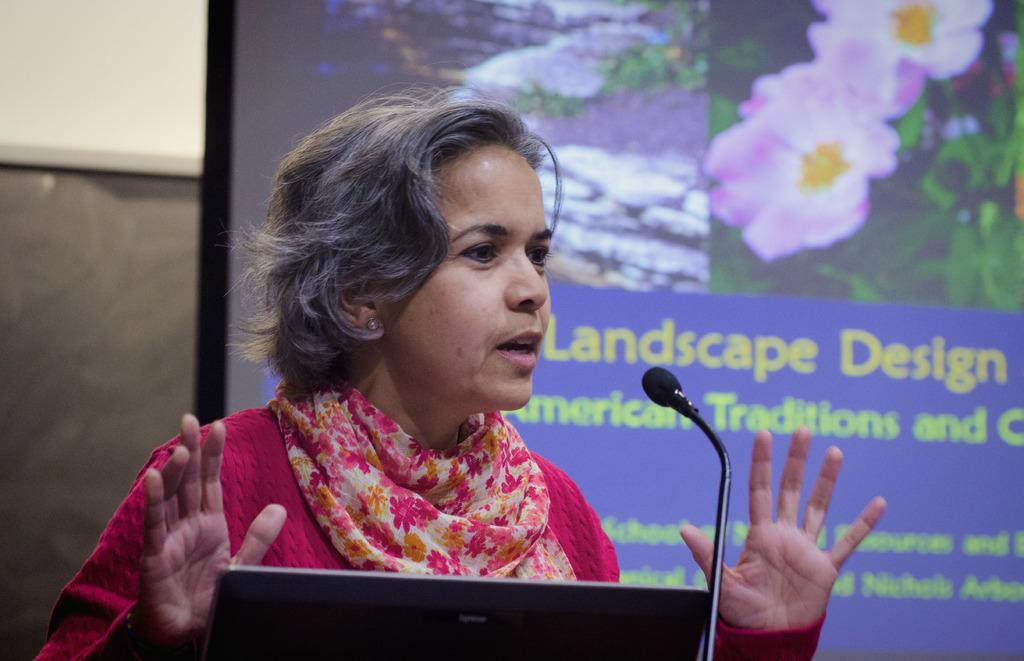What can be seen in the image related to a person? There is a person in the image, and they are wearing a pink top and a scarf. What electronic devices are present in the image? There is a laptop, a mic, and a projector screen in the image. What is written on the projector screen? Something is written on the projector screen, but the specific content is not mentioned in the facts. What is the person likely doing in the image? The presence of a laptop, mic, and projector screen suggests that the person might be giving a presentation or participating in a meeting. Can you describe the seashore in the image? There is no mention of a seashore in the image; it features a person, electronic devices, and a projector screen. What type of yard is visible in the image? There is no yard present in the image; it is an indoor setting with a person, electronic devices, and a projector screen. 